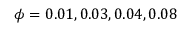<formula> <loc_0><loc_0><loc_500><loc_500>\phi = 0 . 0 1 , 0 . 0 3 , 0 . 0 4 , 0 . 0 8</formula> 